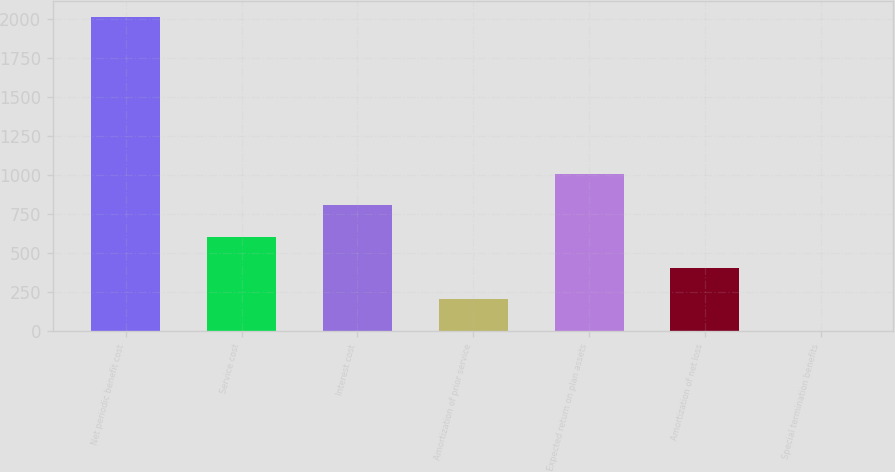Convert chart to OTSL. <chart><loc_0><loc_0><loc_500><loc_500><bar_chart><fcel>Net periodic benefit cost<fcel>Service cost<fcel>Interest cost<fcel>Amortization of prior service<fcel>Expected return on plan assets<fcel>Amortization of net loss<fcel>Special termination benefits<nl><fcel>2016<fcel>606.9<fcel>808.2<fcel>204.3<fcel>1009.5<fcel>405.6<fcel>3<nl></chart> 